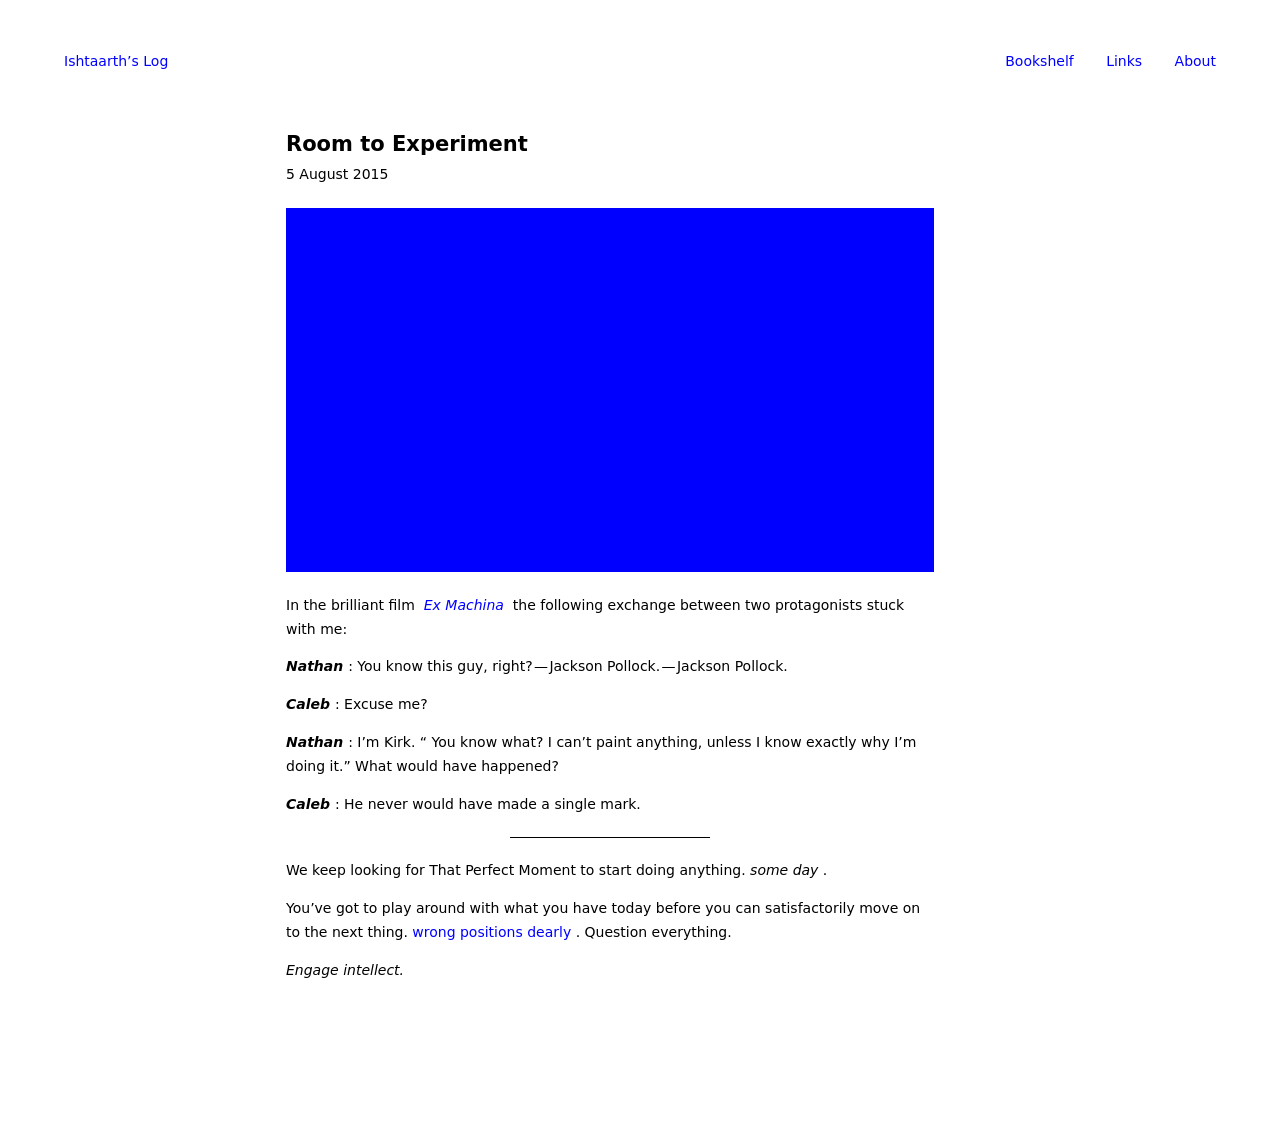How can I start building this website with HTML from the ground up? To start building a website from scratch with HTML, begin by creating a basic structure. First, define the doctype and an HTML tag to encompass your entire webpage. Within that, have a 'head' section for metadata and linking CSS files, and a 'body' section where all visible content will be placed. Here’s a minimal HTML document to get you started:

<!DOCTYPE html>
<html>
<head>
    <title>Your Website Title</title>
</head>
<body>
    <h1>Welcome to My Website</h1>
    <p>This is a paragraph of text on the homepage.</p>
</body>
</html>

This basic structure will display a webpage with a heading and a paragraph. You can expand on this by adding more HTML elements like images, links, lists, and tables to enrich your website's content. 